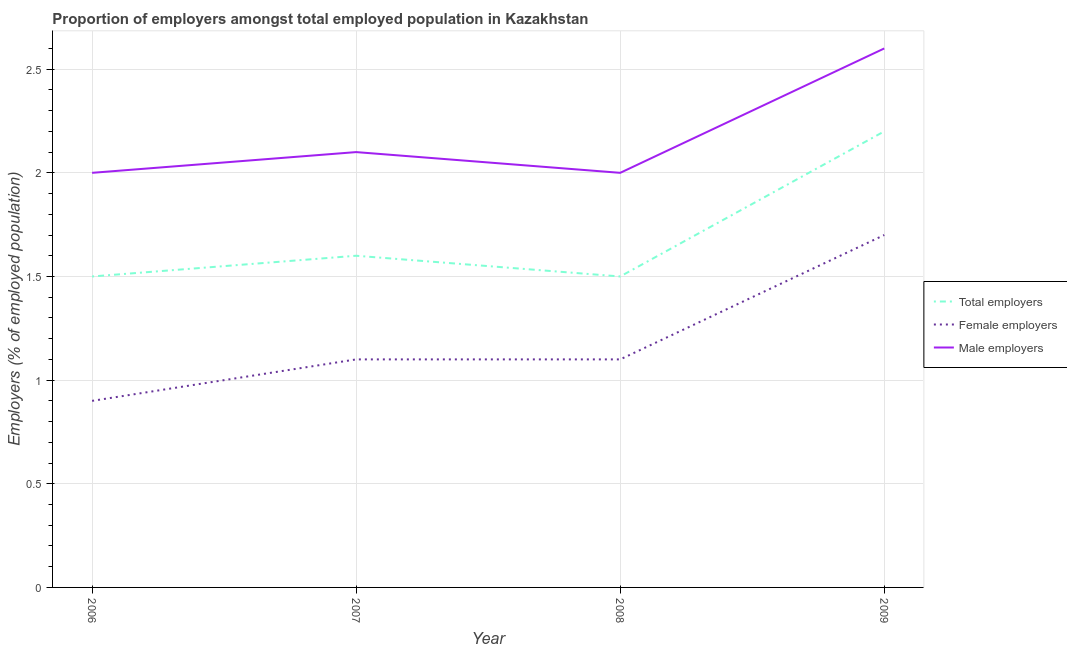What is the percentage of total employers in 2007?
Give a very brief answer. 1.6. Across all years, what is the maximum percentage of total employers?
Offer a very short reply. 2.2. In which year was the percentage of total employers minimum?
Provide a succinct answer. 2006. What is the total percentage of female employers in the graph?
Make the answer very short. 4.8. What is the difference between the percentage of male employers in 2008 and that in 2009?
Your answer should be very brief. -0.6. What is the difference between the percentage of female employers in 2007 and the percentage of male employers in 2006?
Your answer should be compact. -0.9. What is the average percentage of total employers per year?
Offer a very short reply. 1.7. What is the ratio of the percentage of male employers in 2008 to that in 2009?
Your answer should be very brief. 0.77. Is the percentage of female employers in 2008 less than that in 2009?
Offer a terse response. Yes. Is the difference between the percentage of female employers in 2008 and 2009 greater than the difference between the percentage of total employers in 2008 and 2009?
Provide a succinct answer. Yes. What is the difference between the highest and the second highest percentage of total employers?
Offer a very short reply. 0.6. What is the difference between the highest and the lowest percentage of female employers?
Your answer should be compact. 0.8. Is the sum of the percentage of male employers in 2006 and 2007 greater than the maximum percentage of female employers across all years?
Offer a terse response. Yes. Is it the case that in every year, the sum of the percentage of total employers and percentage of female employers is greater than the percentage of male employers?
Your answer should be compact. Yes. Is the percentage of female employers strictly less than the percentage of total employers over the years?
Provide a succinct answer. Yes. How many lines are there?
Offer a very short reply. 3. How many years are there in the graph?
Ensure brevity in your answer.  4. What is the difference between two consecutive major ticks on the Y-axis?
Offer a terse response. 0.5. Does the graph contain grids?
Your answer should be compact. Yes. Where does the legend appear in the graph?
Offer a very short reply. Center right. What is the title of the graph?
Offer a terse response. Proportion of employers amongst total employed population in Kazakhstan. Does "Tertiary" appear as one of the legend labels in the graph?
Your response must be concise. No. What is the label or title of the Y-axis?
Your answer should be very brief. Employers (% of employed population). What is the Employers (% of employed population) in Female employers in 2006?
Your answer should be very brief. 0.9. What is the Employers (% of employed population) in Total employers in 2007?
Ensure brevity in your answer.  1.6. What is the Employers (% of employed population) of Female employers in 2007?
Offer a very short reply. 1.1. What is the Employers (% of employed population) of Male employers in 2007?
Make the answer very short. 2.1. What is the Employers (% of employed population) of Female employers in 2008?
Offer a very short reply. 1.1. What is the Employers (% of employed population) of Male employers in 2008?
Offer a very short reply. 2. What is the Employers (% of employed population) in Total employers in 2009?
Keep it short and to the point. 2.2. What is the Employers (% of employed population) of Female employers in 2009?
Provide a short and direct response. 1.7. What is the Employers (% of employed population) in Male employers in 2009?
Your response must be concise. 2.6. Across all years, what is the maximum Employers (% of employed population) of Total employers?
Your response must be concise. 2.2. Across all years, what is the maximum Employers (% of employed population) of Female employers?
Your response must be concise. 1.7. Across all years, what is the maximum Employers (% of employed population) of Male employers?
Give a very brief answer. 2.6. Across all years, what is the minimum Employers (% of employed population) of Total employers?
Make the answer very short. 1.5. Across all years, what is the minimum Employers (% of employed population) in Female employers?
Offer a very short reply. 0.9. Across all years, what is the minimum Employers (% of employed population) in Male employers?
Your answer should be compact. 2. What is the total Employers (% of employed population) of Total employers in the graph?
Ensure brevity in your answer.  6.8. What is the difference between the Employers (% of employed population) in Total employers in 2006 and that in 2007?
Your answer should be very brief. -0.1. What is the difference between the Employers (% of employed population) of Female employers in 2006 and that in 2007?
Provide a succinct answer. -0.2. What is the difference between the Employers (% of employed population) in Female employers in 2006 and that in 2008?
Make the answer very short. -0.2. What is the difference between the Employers (% of employed population) in Total employers in 2006 and that in 2009?
Your answer should be compact. -0.7. What is the difference between the Employers (% of employed population) in Female employers in 2006 and that in 2009?
Offer a very short reply. -0.8. What is the difference between the Employers (% of employed population) in Total employers in 2007 and that in 2008?
Provide a succinct answer. 0.1. What is the difference between the Employers (% of employed population) in Female employers in 2007 and that in 2008?
Your answer should be compact. 0. What is the difference between the Employers (% of employed population) in Male employers in 2008 and that in 2009?
Your response must be concise. -0.6. What is the difference between the Employers (% of employed population) of Total employers in 2006 and the Employers (% of employed population) of Female employers in 2007?
Keep it short and to the point. 0.4. What is the difference between the Employers (% of employed population) in Total employers in 2006 and the Employers (% of employed population) in Male employers in 2007?
Your response must be concise. -0.6. What is the difference between the Employers (% of employed population) in Total employers in 2006 and the Employers (% of employed population) in Female employers in 2008?
Offer a terse response. 0.4. What is the difference between the Employers (% of employed population) in Total employers in 2006 and the Employers (% of employed population) in Male employers in 2008?
Offer a terse response. -0.5. What is the difference between the Employers (% of employed population) in Female employers in 2006 and the Employers (% of employed population) in Male employers in 2008?
Ensure brevity in your answer.  -1.1. What is the difference between the Employers (% of employed population) of Female employers in 2006 and the Employers (% of employed population) of Male employers in 2009?
Ensure brevity in your answer.  -1.7. What is the difference between the Employers (% of employed population) in Total employers in 2007 and the Employers (% of employed population) in Female employers in 2008?
Your response must be concise. 0.5. What is the difference between the Employers (% of employed population) of Total employers in 2007 and the Employers (% of employed population) of Male employers in 2008?
Your response must be concise. -0.4. What is the difference between the Employers (% of employed population) of Female employers in 2007 and the Employers (% of employed population) of Male employers in 2008?
Provide a succinct answer. -0.9. What is the difference between the Employers (% of employed population) in Total employers in 2007 and the Employers (% of employed population) in Female employers in 2009?
Make the answer very short. -0.1. What is the difference between the Employers (% of employed population) in Female employers in 2008 and the Employers (% of employed population) in Male employers in 2009?
Your response must be concise. -1.5. What is the average Employers (% of employed population) of Total employers per year?
Offer a very short reply. 1.7. What is the average Employers (% of employed population) in Female employers per year?
Your answer should be compact. 1.2. What is the average Employers (% of employed population) in Male employers per year?
Offer a terse response. 2.17. In the year 2006, what is the difference between the Employers (% of employed population) in Female employers and Employers (% of employed population) in Male employers?
Your response must be concise. -1.1. In the year 2008, what is the difference between the Employers (% of employed population) in Total employers and Employers (% of employed population) in Male employers?
Offer a terse response. -0.5. In the year 2008, what is the difference between the Employers (% of employed population) of Female employers and Employers (% of employed population) of Male employers?
Keep it short and to the point. -0.9. In the year 2009, what is the difference between the Employers (% of employed population) in Total employers and Employers (% of employed population) in Female employers?
Give a very brief answer. 0.5. In the year 2009, what is the difference between the Employers (% of employed population) of Female employers and Employers (% of employed population) of Male employers?
Offer a very short reply. -0.9. What is the ratio of the Employers (% of employed population) of Total employers in 2006 to that in 2007?
Provide a short and direct response. 0.94. What is the ratio of the Employers (% of employed population) of Female employers in 2006 to that in 2007?
Provide a short and direct response. 0.82. What is the ratio of the Employers (% of employed population) in Total employers in 2006 to that in 2008?
Provide a succinct answer. 1. What is the ratio of the Employers (% of employed population) in Female employers in 2006 to that in 2008?
Your answer should be very brief. 0.82. What is the ratio of the Employers (% of employed population) of Male employers in 2006 to that in 2008?
Offer a very short reply. 1. What is the ratio of the Employers (% of employed population) in Total employers in 2006 to that in 2009?
Ensure brevity in your answer.  0.68. What is the ratio of the Employers (% of employed population) in Female employers in 2006 to that in 2009?
Provide a succinct answer. 0.53. What is the ratio of the Employers (% of employed population) of Male employers in 2006 to that in 2009?
Make the answer very short. 0.77. What is the ratio of the Employers (% of employed population) of Total employers in 2007 to that in 2008?
Provide a succinct answer. 1.07. What is the ratio of the Employers (% of employed population) in Total employers in 2007 to that in 2009?
Your answer should be compact. 0.73. What is the ratio of the Employers (% of employed population) in Female employers in 2007 to that in 2009?
Make the answer very short. 0.65. What is the ratio of the Employers (% of employed population) of Male employers in 2007 to that in 2009?
Ensure brevity in your answer.  0.81. What is the ratio of the Employers (% of employed population) in Total employers in 2008 to that in 2009?
Provide a succinct answer. 0.68. What is the ratio of the Employers (% of employed population) of Female employers in 2008 to that in 2009?
Keep it short and to the point. 0.65. What is the ratio of the Employers (% of employed population) of Male employers in 2008 to that in 2009?
Your response must be concise. 0.77. What is the difference between the highest and the second highest Employers (% of employed population) in Female employers?
Ensure brevity in your answer.  0.6. What is the difference between the highest and the second highest Employers (% of employed population) of Male employers?
Provide a succinct answer. 0.5. What is the difference between the highest and the lowest Employers (% of employed population) in Total employers?
Offer a terse response. 0.7. What is the difference between the highest and the lowest Employers (% of employed population) in Female employers?
Offer a very short reply. 0.8. 